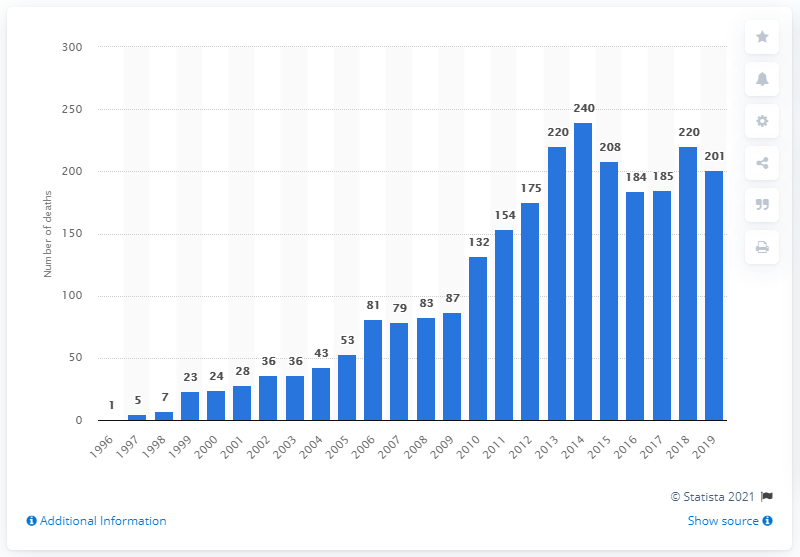List a handful of essential elements in this visual. In 2014, there were 240 deaths resulting from tramadol drug poisoning reported. The largest number of deaths from tramadol drug poisoning was recorded in 2014. 